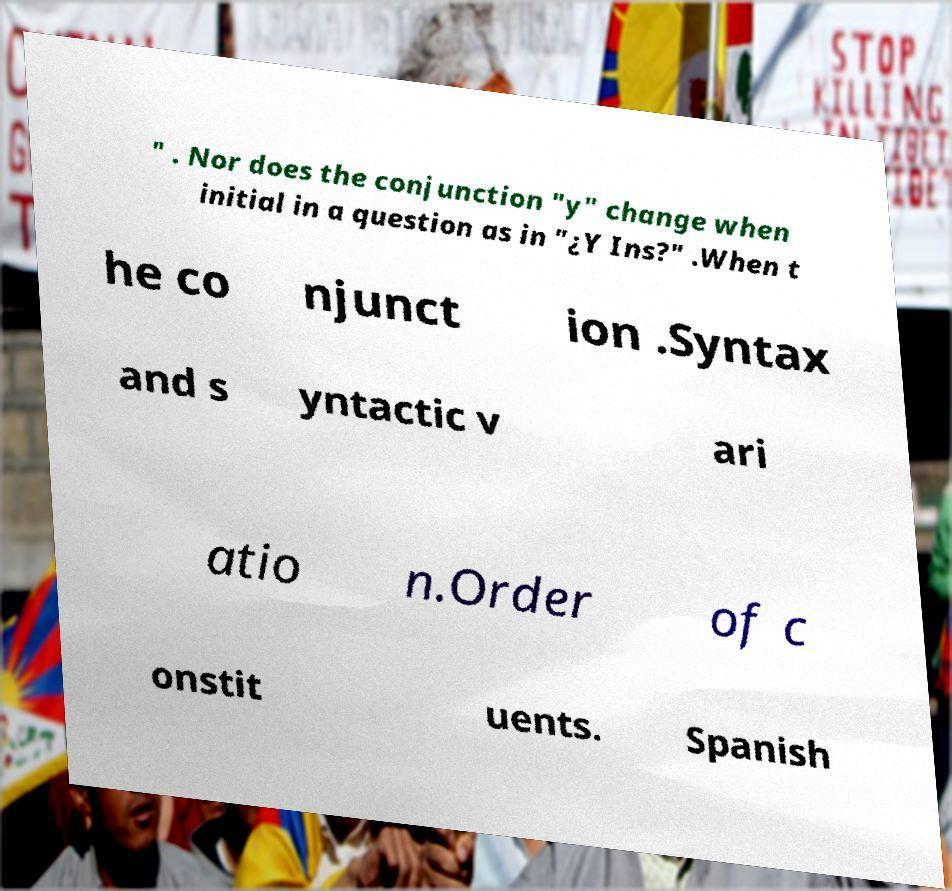There's text embedded in this image that I need extracted. Can you transcribe it verbatim? " . Nor does the conjunction "y" change when initial in a question as in "¿Y Ins?" .When t he co njunct ion .Syntax and s yntactic v ari atio n.Order of c onstit uents. Spanish 